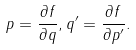<formula> <loc_0><loc_0><loc_500><loc_500>p = \frac { \partial f } { \partial q } , q ^ { \prime } = \frac { \partial f } { \partial p ^ { \prime } } .</formula> 